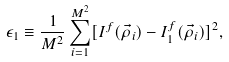Convert formula to latex. <formula><loc_0><loc_0><loc_500><loc_500>\epsilon _ { 1 } \equiv \frac { 1 } { M ^ { 2 } } \sum _ { i = 1 } ^ { M ^ { 2 } } [ I ^ { f } ( \vec { \rho } _ { i } ) - I ^ { f } _ { 1 } ( \vec { \rho } _ { i } ) ] ^ { 2 } ,</formula> 